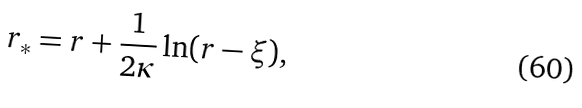<formula> <loc_0><loc_0><loc_500><loc_500>r _ { * } = r + \frac { 1 } { 2 \kappa } \ln ( r - \xi ) ,</formula> 